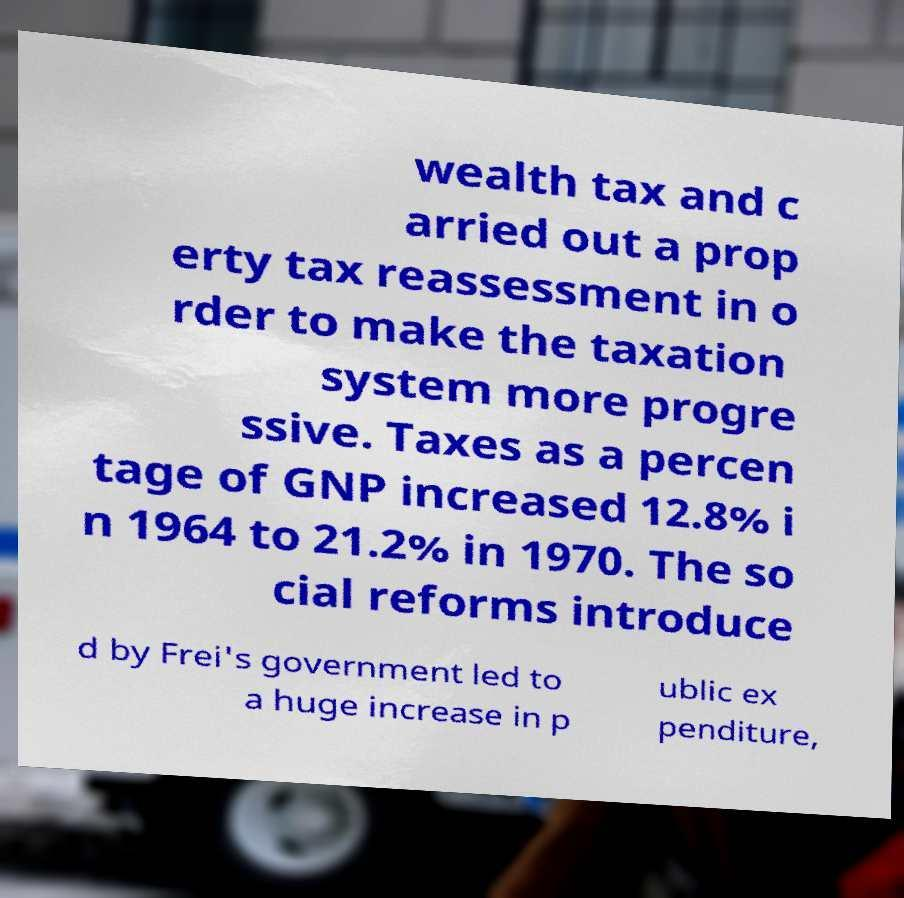I need the written content from this picture converted into text. Can you do that? wealth tax and c arried out a prop erty tax reassessment in o rder to make the taxation system more progre ssive. Taxes as a percen tage of GNP increased 12.8% i n 1964 to 21.2% in 1970. The so cial reforms introduce d by Frei's government led to a huge increase in p ublic ex penditure, 